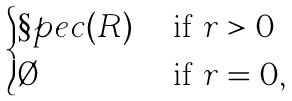<formula> <loc_0><loc_0><loc_500><loc_500>\begin{cases} \S p e c ( R ) & \text { if } r > 0 \\ \emptyset & \text { if } r = 0 , \end{cases}</formula> 